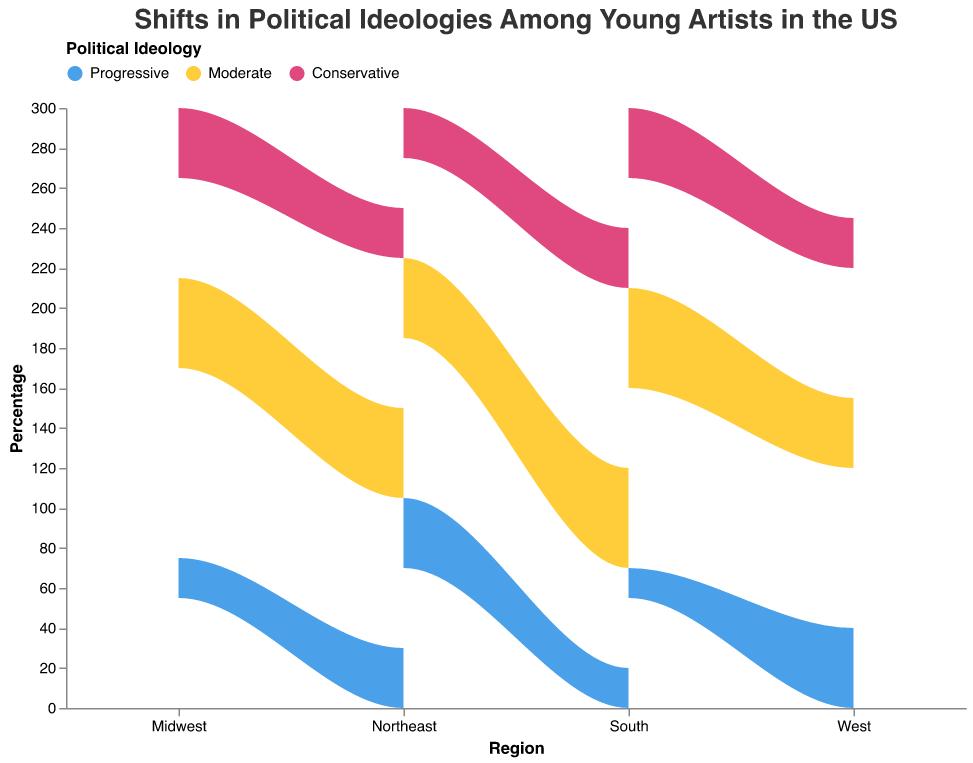What is the title of the stream graph? The title of the graph is displayed at the top in a larger font size. It provides a summary of what the graph is about.
Answer: Shifts in Political Ideologies Among Young Artists in the US Which region has the highest percentage of Progressive young artists overall? To find the highest percentage of Progressive young artists, look at the topmost layer for Progressive representation in each region. Compare the values visually.
Answer: West What is the percentage of Conservative young artists in the Midwest across all ethnic backgrounds? To find this, sum up the percentages of Conservative representation for each ethnic background in the Midwest: Hispanic/Latino (25%), African American (25%), and White (35%).
Answer: 85% Which ethnic background in the Northeast has the highest percentage of Moderates? Examine the Moderate layer in the Northeast category and identify which ethnic background has the highest percentage. Compare each group visually.
Answer: Hispanic/Latino Compare the percentage of Progressive young artists between the African American group in the Northeast and the West. Identify the Progressive layer for African Americans in both the Northeast and the West and compare their respective percentages.
Answer: The West has a higher percentage What is the combined percentage of Moderate and Conservative Hispanic/Latino young artists in the South? Add the percentage of Moderates (50%) and Conservatives (30%) for Hispanic/Latino in the South.
Answer: 80% How many percentage points higher is the proportion of Progressive African American young artists in the West compared to the Midwest? Subtract the percentage of Progressive African American young artists in the Midwest (30%) from that in the West (45%).
Answer: 15 percentage points Which region has the lowest percentage of Progressive young artists among the White ethnic group? Visually identify and compare the areas representing Progressives within the White ethnic group across all regions.
Answer: South What is the difference in the percentage of Conservative young artists between Hispanic/Latino and White ethnic backgrounds in the West? Subtract the percentage of Conservative young artists in the Hispanic/Latino group (25%) from that in the White group (30%) in the West.
Answer: 5 percentage points Identify the region and ethnic background combination with the smallest overall percentage of Conservative young artists. Scan each region-ethnic combination's Conservative layer and identify the combination with the smallest visual representation percentage.
Answer: Tie: All ethnic groups in the Northeast, African Americans in the West (25%) 